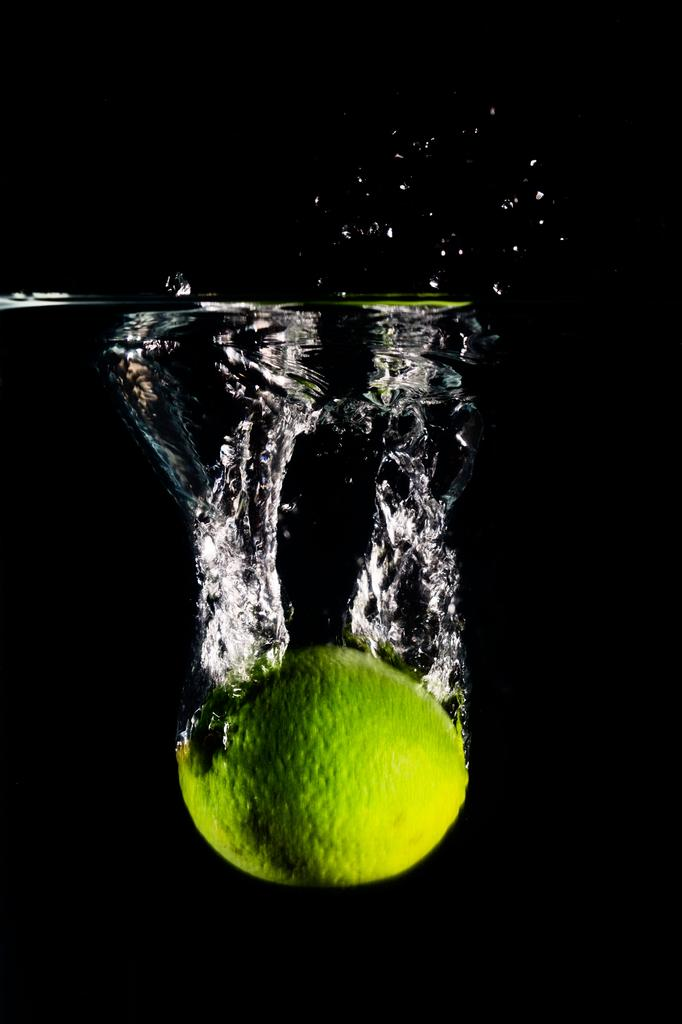What object is in the water in the image? There is a tennis ball in the water. How many buckets of water are present in the image? There is no bucket present in the image, only a tennis ball in the water. What type of mitten can be seen being used to play with the tennis ball in the image? There is no mitten present in the image, and the tennis ball is in the water without any mittens. 